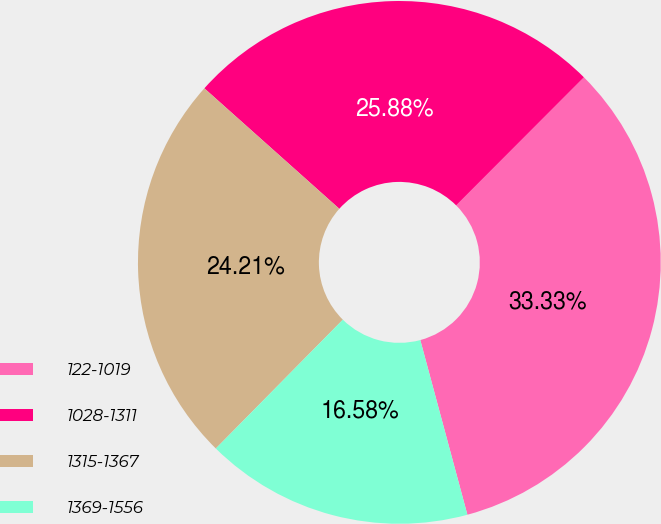Convert chart. <chart><loc_0><loc_0><loc_500><loc_500><pie_chart><fcel>122-1019<fcel>1028-1311<fcel>1315-1367<fcel>1369-1556<nl><fcel>33.33%<fcel>25.88%<fcel>24.21%<fcel>16.58%<nl></chart> 